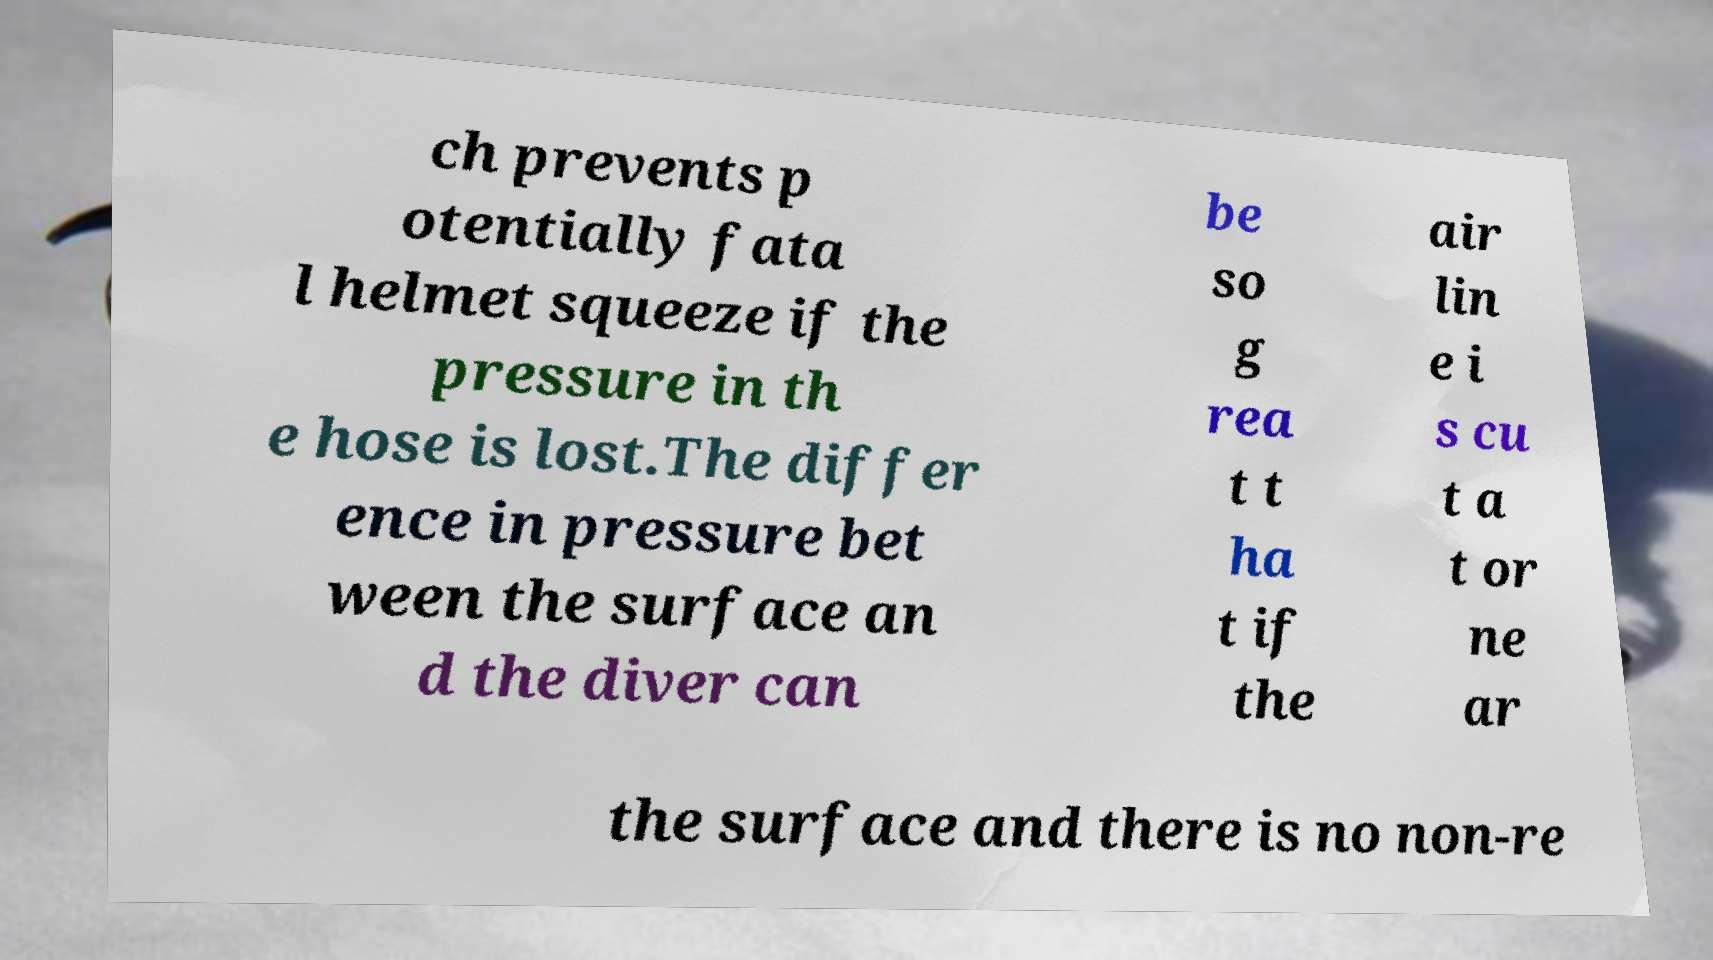Could you extract and type out the text from this image? ch prevents p otentially fata l helmet squeeze if the pressure in th e hose is lost.The differ ence in pressure bet ween the surface an d the diver can be so g rea t t ha t if the air lin e i s cu t a t or ne ar the surface and there is no non-re 